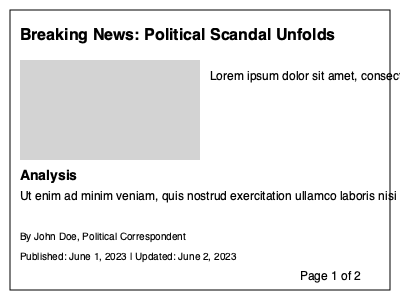In the given news article layout, which element is typically considered the most crucial for capturing readers' attention and conveying the article's main topic? To identify the most crucial element in a news article layout for capturing readers' attention and conveying the main topic, we need to consider the following:

1. Headline: Located at the top of the article, it's the largest text that reads "Breaking News: Political Scandal Unfolds". Headlines are designed to be eye-catching and summarize the main story.

2. Image: Represented by the gray rectangle, images are visually appealing and can quickly convey information.

3. Lead paragraph: The text immediately following the headline provides a summary of the key points.

4. Analysis section: While important, this is typically supplementary to the main story.

5. Byline and publication date: These provide context but are not the main focus.

6. Page number: This is purely navigational and not related to the content.

Among these elements, the headline is generally considered the most crucial. It's the first thing readers see, it's prominently displayed with the largest font size, and it succinctly conveys the article's main topic. The headline serves as the primary hook to grab readers' attention and entice them to read further.

For a literary agent specializing in representing journalists and political commentators, understanding the importance of headlines is crucial. A well-crafted headline can significantly impact an article's readership and, consequently, a journalist's or commentator's visibility and influence.
Answer: Headline 